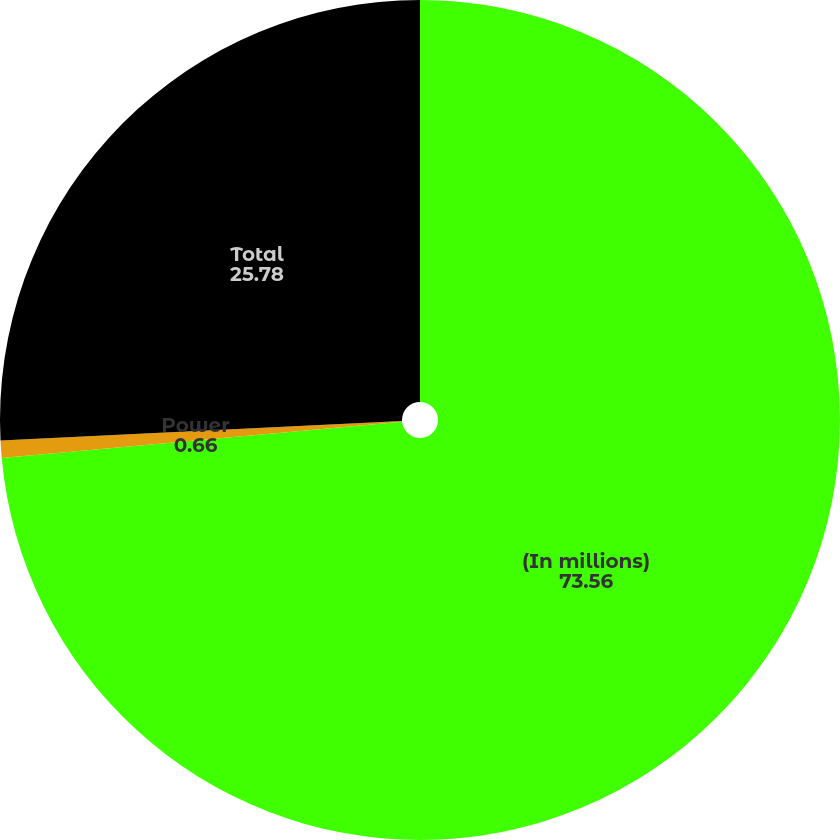Convert chart to OTSL. <chart><loc_0><loc_0><loc_500><loc_500><pie_chart><fcel>(In millions)<fcel>Power<fcel>Total<nl><fcel>73.56%<fcel>0.66%<fcel>25.78%<nl></chart> 